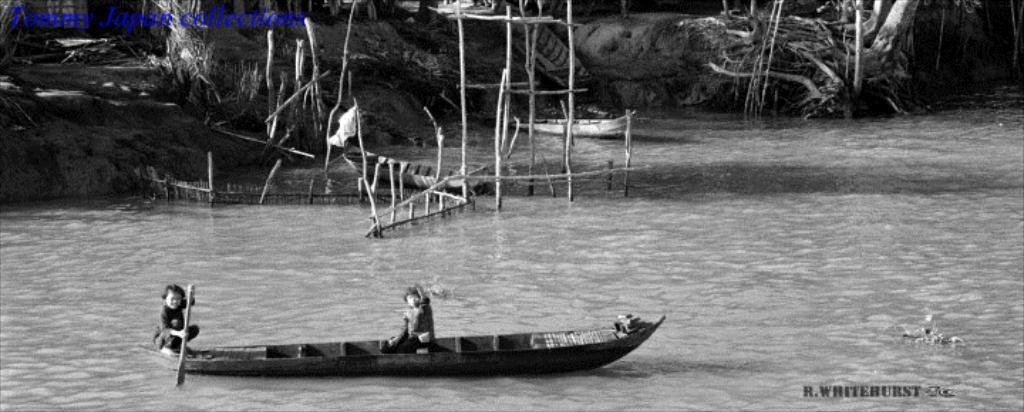What are the two boys doing in the image? The two boys are in a canoe in the foreground of the image. Where is the canoe located? The canoe is in the water. What can be seen in the background of the image? In the background, there are sticks, a canoe, trees, and water. What type of hose is connected to the mailbox in the image? There is no hose or mailbox present in the image. What kind of system is being used by the boys to navigate the canoe in the image? The image does not show any specific system being used by the boys to navigate the canoe; they are simply in the water. 